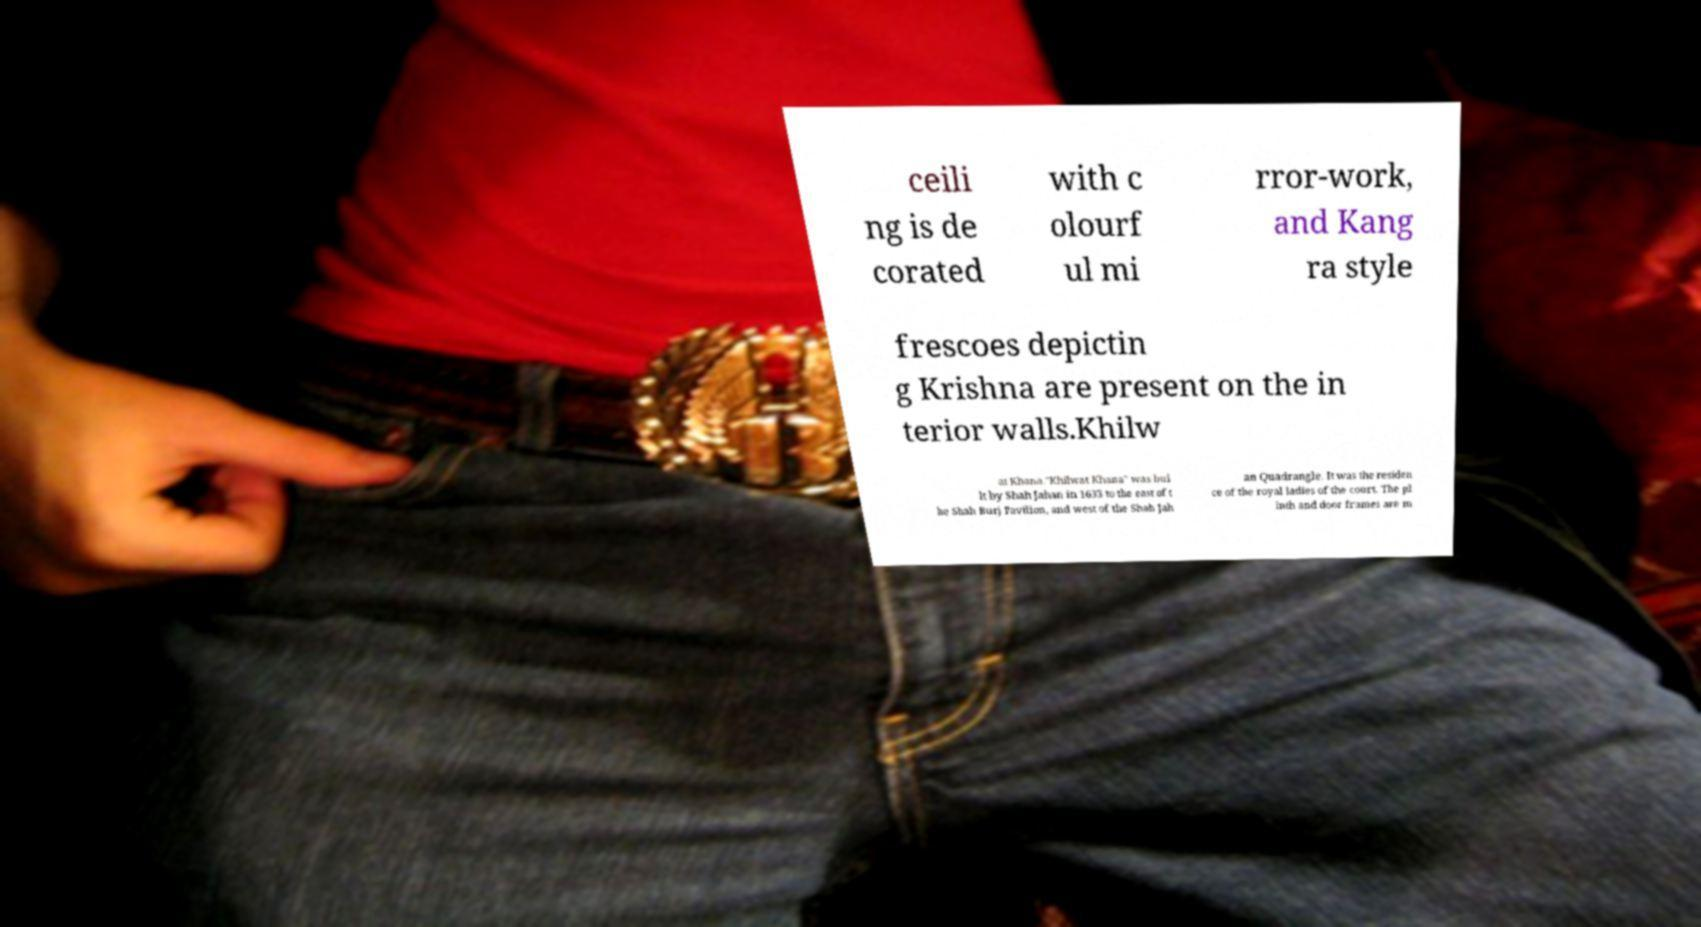For documentation purposes, I need the text within this image transcribed. Could you provide that? ceili ng is de corated with c olourf ul mi rror-work, and Kang ra style frescoes depictin g Krishna are present on the in terior walls.Khilw at Khana."Khilwat Khana" was bui lt by Shah Jahan in 1633 to the east of t he Shah Burj Pavilion, and west of the Shah Jah an Quadrangle. It was the residen ce of the royal ladies of the court. The pl inth and door frames are m 